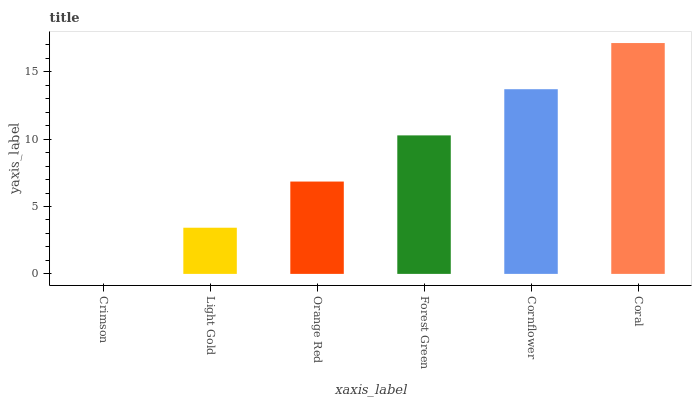Is Crimson the minimum?
Answer yes or no. Yes. Is Coral the maximum?
Answer yes or no. Yes. Is Light Gold the minimum?
Answer yes or no. No. Is Light Gold the maximum?
Answer yes or no. No. Is Light Gold greater than Crimson?
Answer yes or no. Yes. Is Crimson less than Light Gold?
Answer yes or no. Yes. Is Crimson greater than Light Gold?
Answer yes or no. No. Is Light Gold less than Crimson?
Answer yes or no. No. Is Forest Green the high median?
Answer yes or no. Yes. Is Orange Red the low median?
Answer yes or no. Yes. Is Orange Red the high median?
Answer yes or no. No. Is Forest Green the low median?
Answer yes or no. No. 